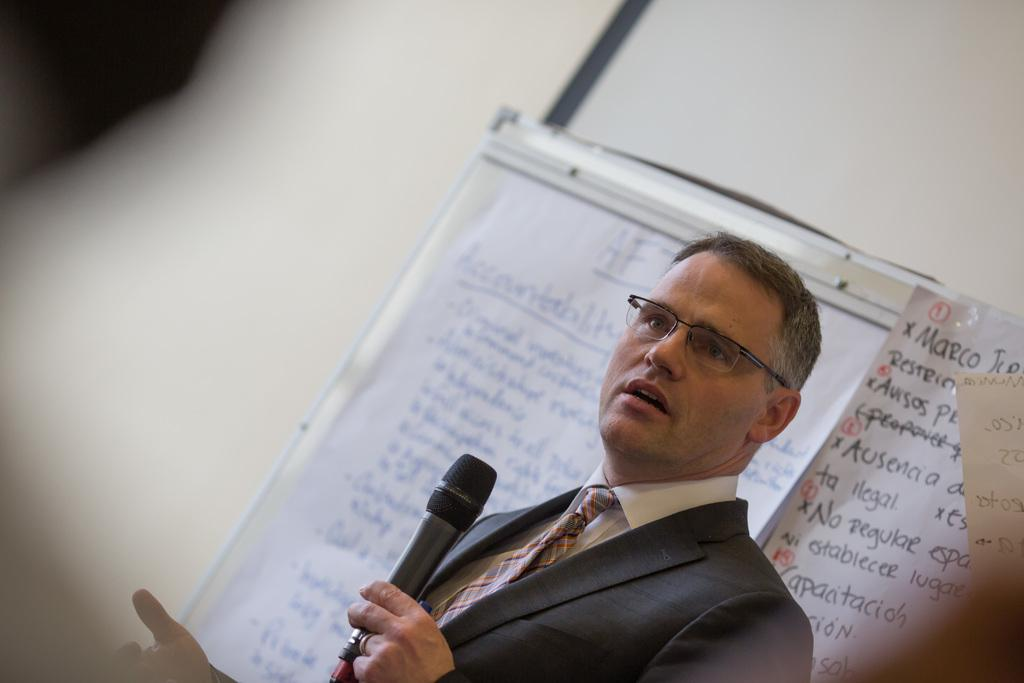What is the main subject of the image? The main subject of the image is a man. Can you describe the man's appearance? The man is wearing clothes, spectacles, and a finger ring. What is the man holding in the image? The man is holding a microphone. What can be seen in the background of the image? There are white charts visible in the background, with text on them, and a wall. What is the name of the actor in the image? There is no actor present in the image; it features a man holding a microphone. What type of harmony is being demonstrated in the image? There is no harmony being demonstrated in the image; it focuses on a man holding a microphone and the background elements. 